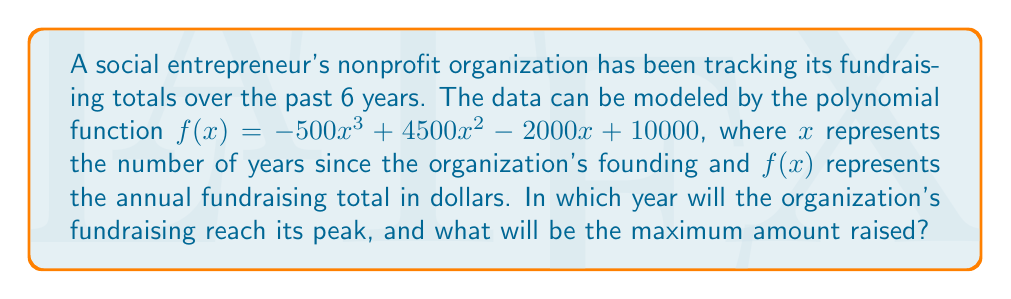Help me with this question. To find the year of peak fundraising and the maximum amount raised, we need to follow these steps:

1) First, we need to find the derivative of the function to determine where the maximum occurs:
   $f'(x) = -1500x^2 + 9000x - 2000$

2) Set the derivative equal to zero and solve for x:
   $-1500x^2 + 9000x - 2000 = 0$

3) This is a quadratic equation. We can solve it using the quadratic formula:
   $x = \frac{-b \pm \sqrt{b^2 - 4ac}}{2a}$

   Where $a = -1500$, $b = 9000$, and $c = -2000$

4) Plugging in these values:
   $x = \frac{-9000 \pm \sqrt{9000^2 - 4(-1500)(-2000)}}{2(-1500)}$
   $= \frac{-9000 \pm \sqrt{81000000 - 12000000}}{-3000}$
   $= \frac{-9000 \pm \sqrt{69000000}}{-3000}$
   $= \frac{-9000 \pm 8306.62}{-3000}$

5) This gives us two solutions:
   $x_1 = \frac{-9000 + 8306.62}{-3000} = 0.23$
   $x_2 = \frac{-9000 - 8306.62}{-3000} = 5.77$

6) Since we're looking for a maximum, and the leading coefficient of our original function is negative (indicating the parabola opens downward), we choose the larger value: $x = 5.77$

7) This means the fundraising will peak 5.77 years after the organization's founding, or in the 6th year.

8) To find the maximum amount raised, we plug this x-value back into our original function:
   $f(5.77) = -500(5.77)^3 + 4500(5.77)^2 - 2000(5.77) + 10000$
   $= -500(191.85) + 4500(33.29) - 2000(5.77) + 10000$
   $= -95925 + 149805 - 11540 + 10000$
   $= 52340$

Therefore, the fundraising will peak in the 6th year, raising a maximum of $52,340.
Answer: 6th year; $52,340 